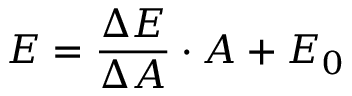<formula> <loc_0><loc_0><loc_500><loc_500>E = \frac { \Delta E } { \Delta A } \cdot A + E _ { 0 }</formula> 